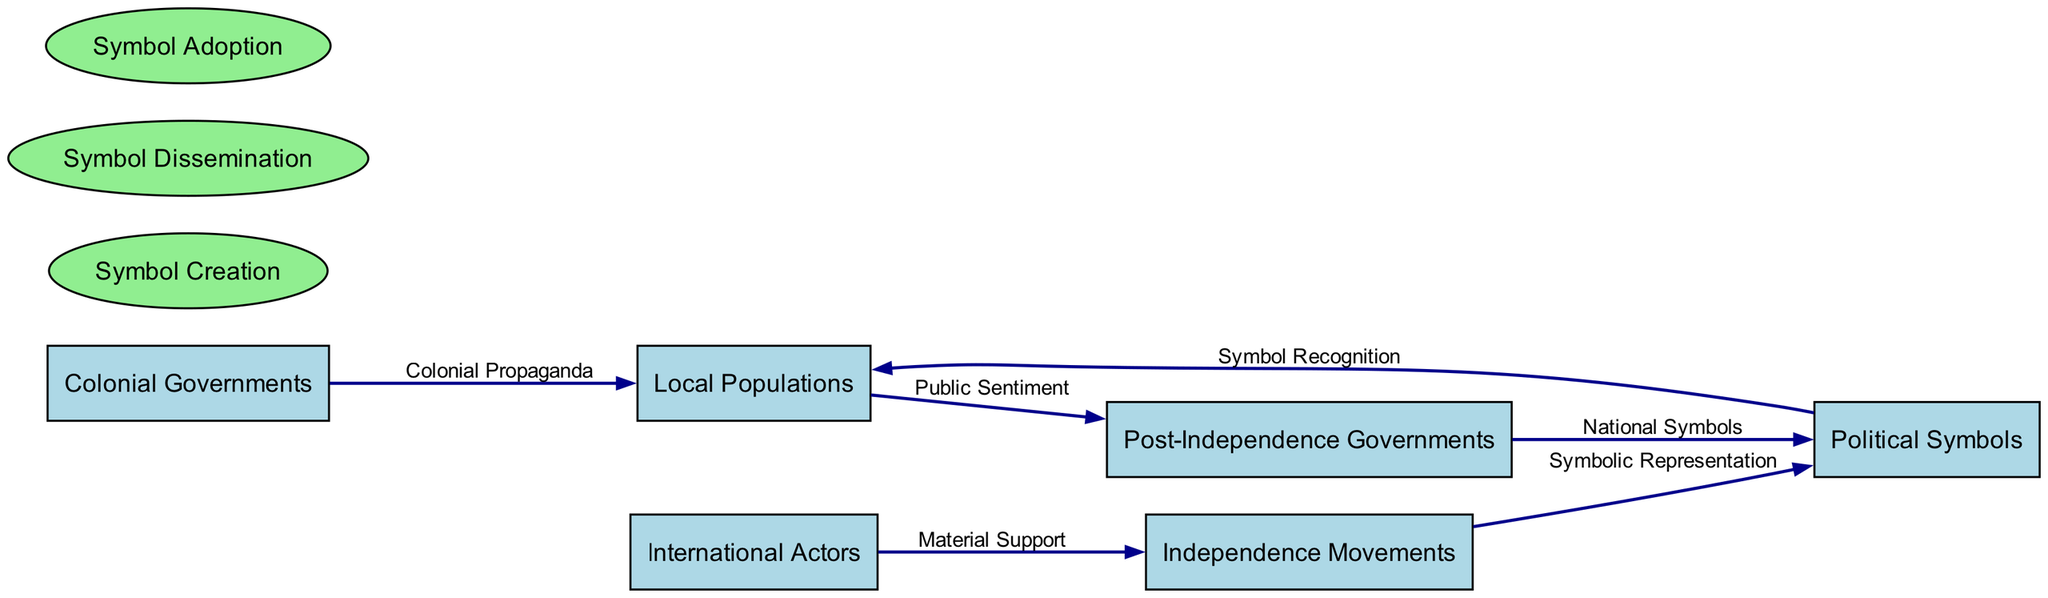What are the two main categories represented in the diagram? The diagram includes entities and processes as the two main categories. Entities consist of different groups and actors involved, while processes indicate various functions related to political symbols in the independence movements.
Answer: entities and processes How many entities are depicted in the diagram? By counting the distinct entities listed in the diagram, we identify a total of six entities: Colonial Governments, Independence Movements, Political Symbols, Local Populations, International Actors, and Post-Independence Governments.
Answer: 6 Which entity provides "Public Sentiment"? The "Public Sentiment" data flow originates from Local Populations, indicating that this group expresses the collective attitude and support towards the newly formed Post-Independence Governments.
Answer: Local Populations What type of support is provided by International Actors to Independence Movements? International Actors provide "Material Support," which includes logistical, financial, and political assistance to the independence movements, as indicated in the data flow description.
Answer: Material Support What is the process involved in creating political symbols? The diagram identifies "Symbol Creation" as the process that involves independence movements in designing and creating political symbols, highlighting the initial effort to establish these representations.
Answer: Symbol Creation How many data flows lead into Political Symbols? There are three data flows leading into Political Symbols: from Independence Movements (Symbolic Representation), from Local Populations (Symbol Recognition), and from Post-Independence Governments (National Symbols). This shows the multifaceted role of symbols in different contexts.
Answer: 3 Which process is related to the dissemination of political symbols? The process referred to for the dissemination of political symbols is called "Symbol Dissemination," highlighting how these symbols are distributed and promoted among local populations to build a collective identity.
Answer: Symbol Dissemination What is the connection between Independence Movements and Local Populations? The data flow from Independence Movements to Political Symbols indicates the creation of symbolic representations aimed at local populations. Then, from Political Symbols to Local Populations, there's an emphasis on recognition, showing a direct influence of the movements on the identity perception of local communities.
Answer: Symbolic Representation and Symbol Recognition How do Post-Independence Governments interact with Political Symbols? Post-Independence Governments adopt and modify Political Symbols, as denoted in the data flow labeled "National Symbols," representing the new national identity formed after independence.
Answer: National Symbols 